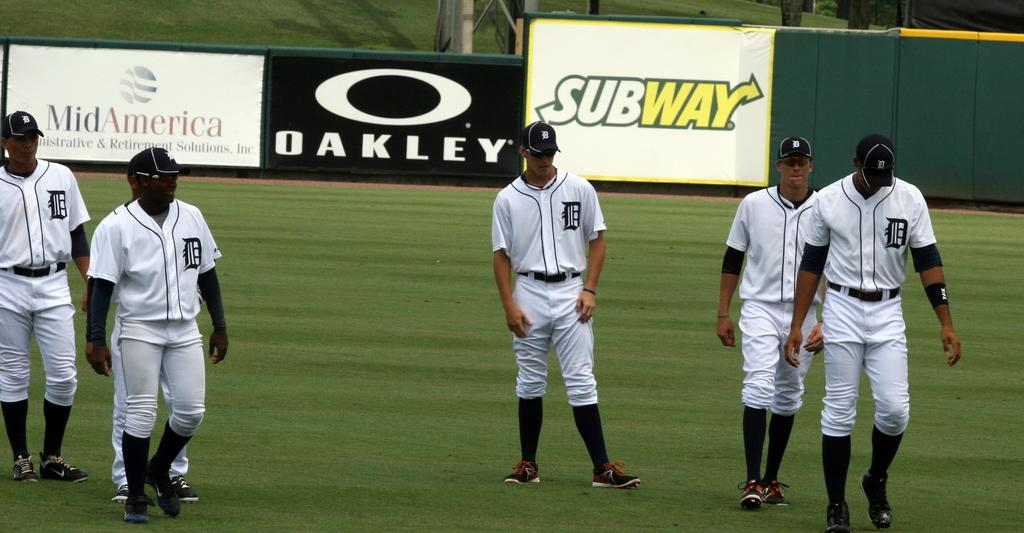<image>
Offer a succinct explanation of the picture presented. An advertisement for Oakley is among other ads around a baseball field. 